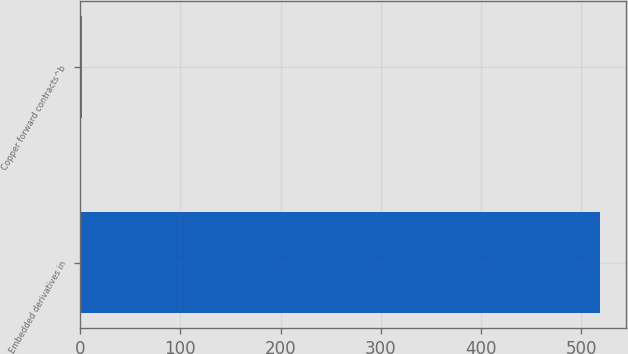Convert chart to OTSL. <chart><loc_0><loc_0><loc_500><loc_500><bar_chart><fcel>Embedded derivatives in<fcel>Copper forward contracts^b<nl><fcel>519<fcel>2<nl></chart> 